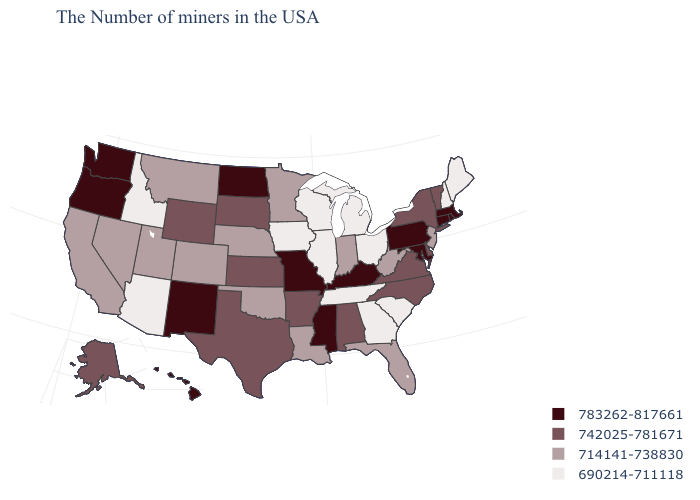Name the states that have a value in the range 690214-711118?
Give a very brief answer. Maine, New Hampshire, South Carolina, Ohio, Georgia, Michigan, Tennessee, Wisconsin, Illinois, Iowa, Arizona, Idaho. Name the states that have a value in the range 742025-781671?
Keep it brief. Vermont, New York, Delaware, Virginia, North Carolina, Alabama, Arkansas, Kansas, Texas, South Dakota, Wyoming, Alaska. What is the highest value in states that border Montana?
Concise answer only. 783262-817661. Name the states that have a value in the range 783262-817661?
Keep it brief. Massachusetts, Rhode Island, Connecticut, Maryland, Pennsylvania, Kentucky, Mississippi, Missouri, North Dakota, New Mexico, Washington, Oregon, Hawaii. What is the value of Missouri?
Keep it brief. 783262-817661. Name the states that have a value in the range 783262-817661?
Concise answer only. Massachusetts, Rhode Island, Connecticut, Maryland, Pennsylvania, Kentucky, Mississippi, Missouri, North Dakota, New Mexico, Washington, Oregon, Hawaii. What is the lowest value in states that border Mississippi?
Give a very brief answer. 690214-711118. Which states hav the highest value in the West?
Write a very short answer. New Mexico, Washington, Oregon, Hawaii. What is the highest value in the USA?
Be succinct. 783262-817661. What is the value of Tennessee?
Give a very brief answer. 690214-711118. Does Michigan have a lower value than New Mexico?
Concise answer only. Yes. What is the highest value in states that border Colorado?
Concise answer only. 783262-817661. Does the map have missing data?
Write a very short answer. No. Does the first symbol in the legend represent the smallest category?
Keep it brief. No. 